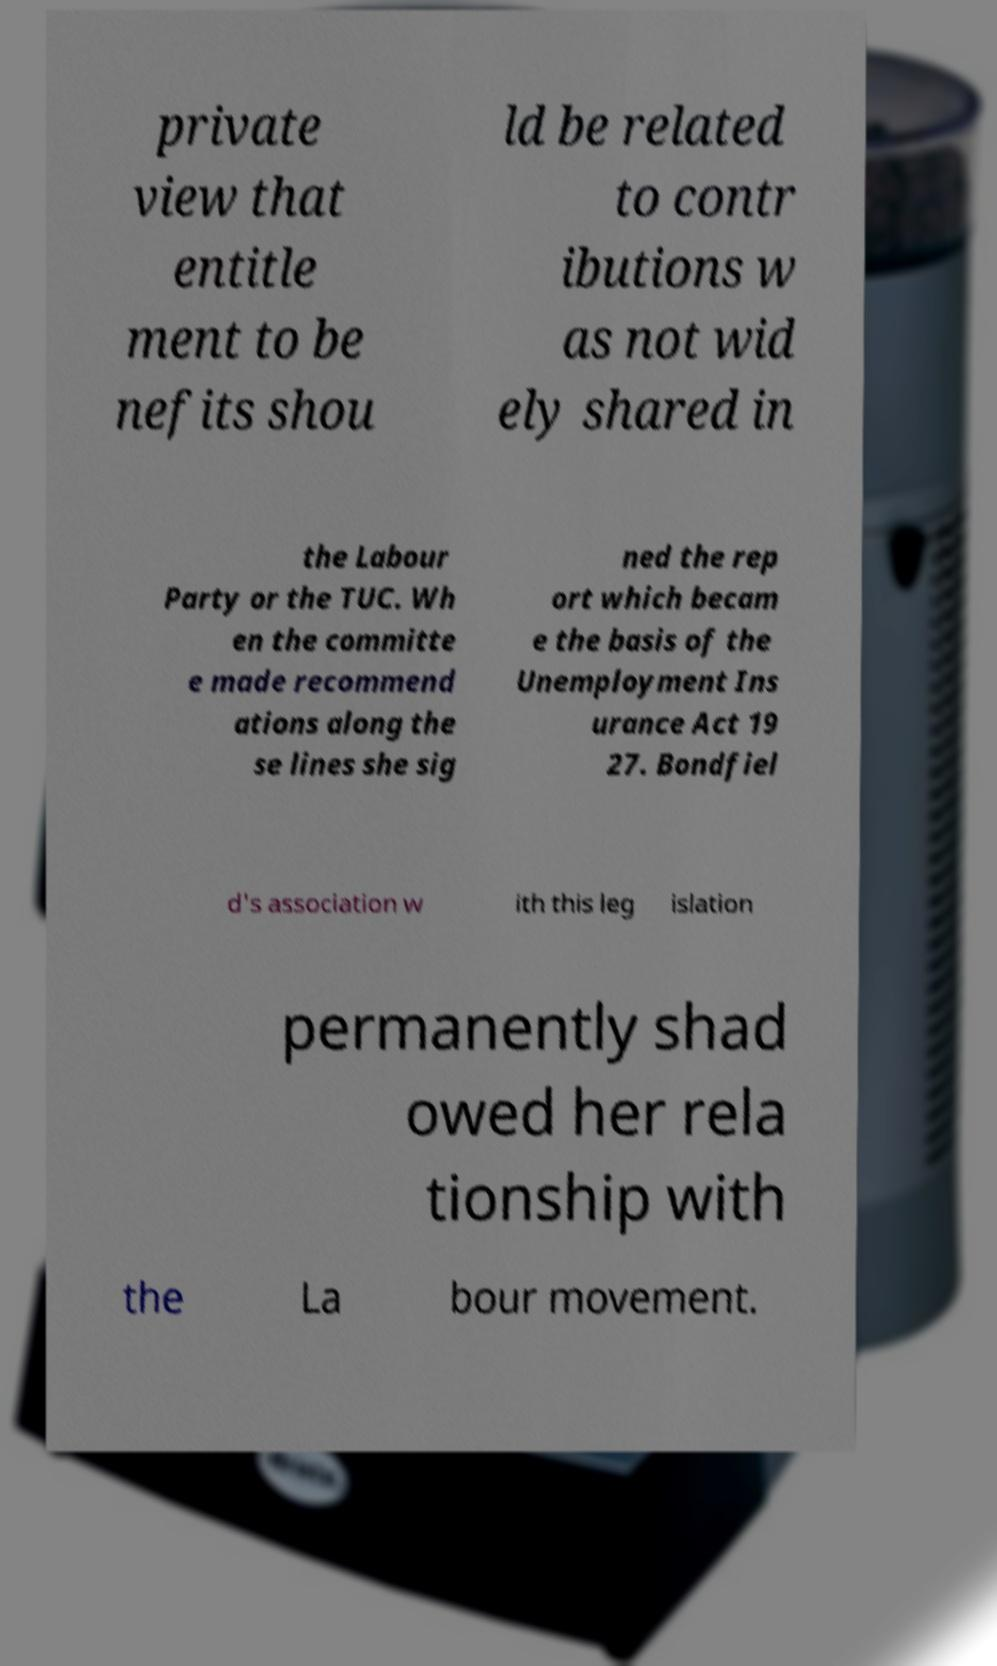Could you extract and type out the text from this image? private view that entitle ment to be nefits shou ld be related to contr ibutions w as not wid ely shared in the Labour Party or the TUC. Wh en the committe e made recommend ations along the se lines she sig ned the rep ort which becam e the basis of the Unemployment Ins urance Act 19 27. Bondfiel d's association w ith this leg islation permanently shad owed her rela tionship with the La bour movement. 